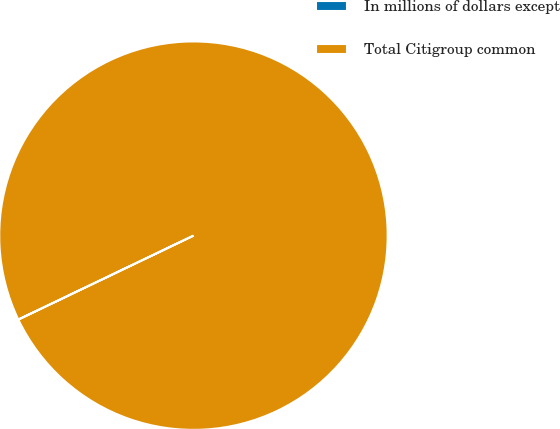Convert chart. <chart><loc_0><loc_0><loc_500><loc_500><pie_chart><fcel>In millions of dollars except<fcel>Total Citigroup common<nl><fcel>0.01%<fcel>99.99%<nl></chart> 